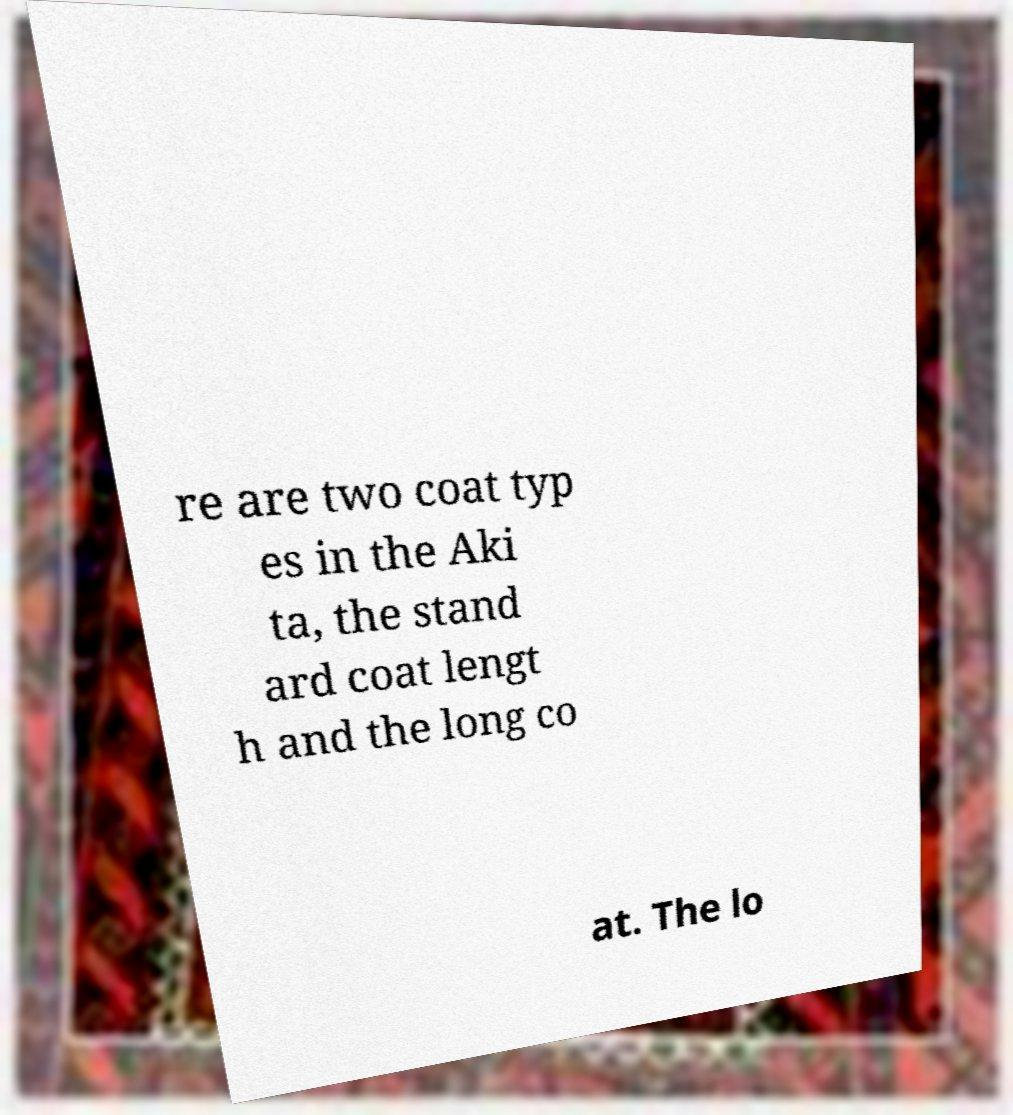Could you assist in decoding the text presented in this image and type it out clearly? re are two coat typ es in the Aki ta, the stand ard coat lengt h and the long co at. The lo 